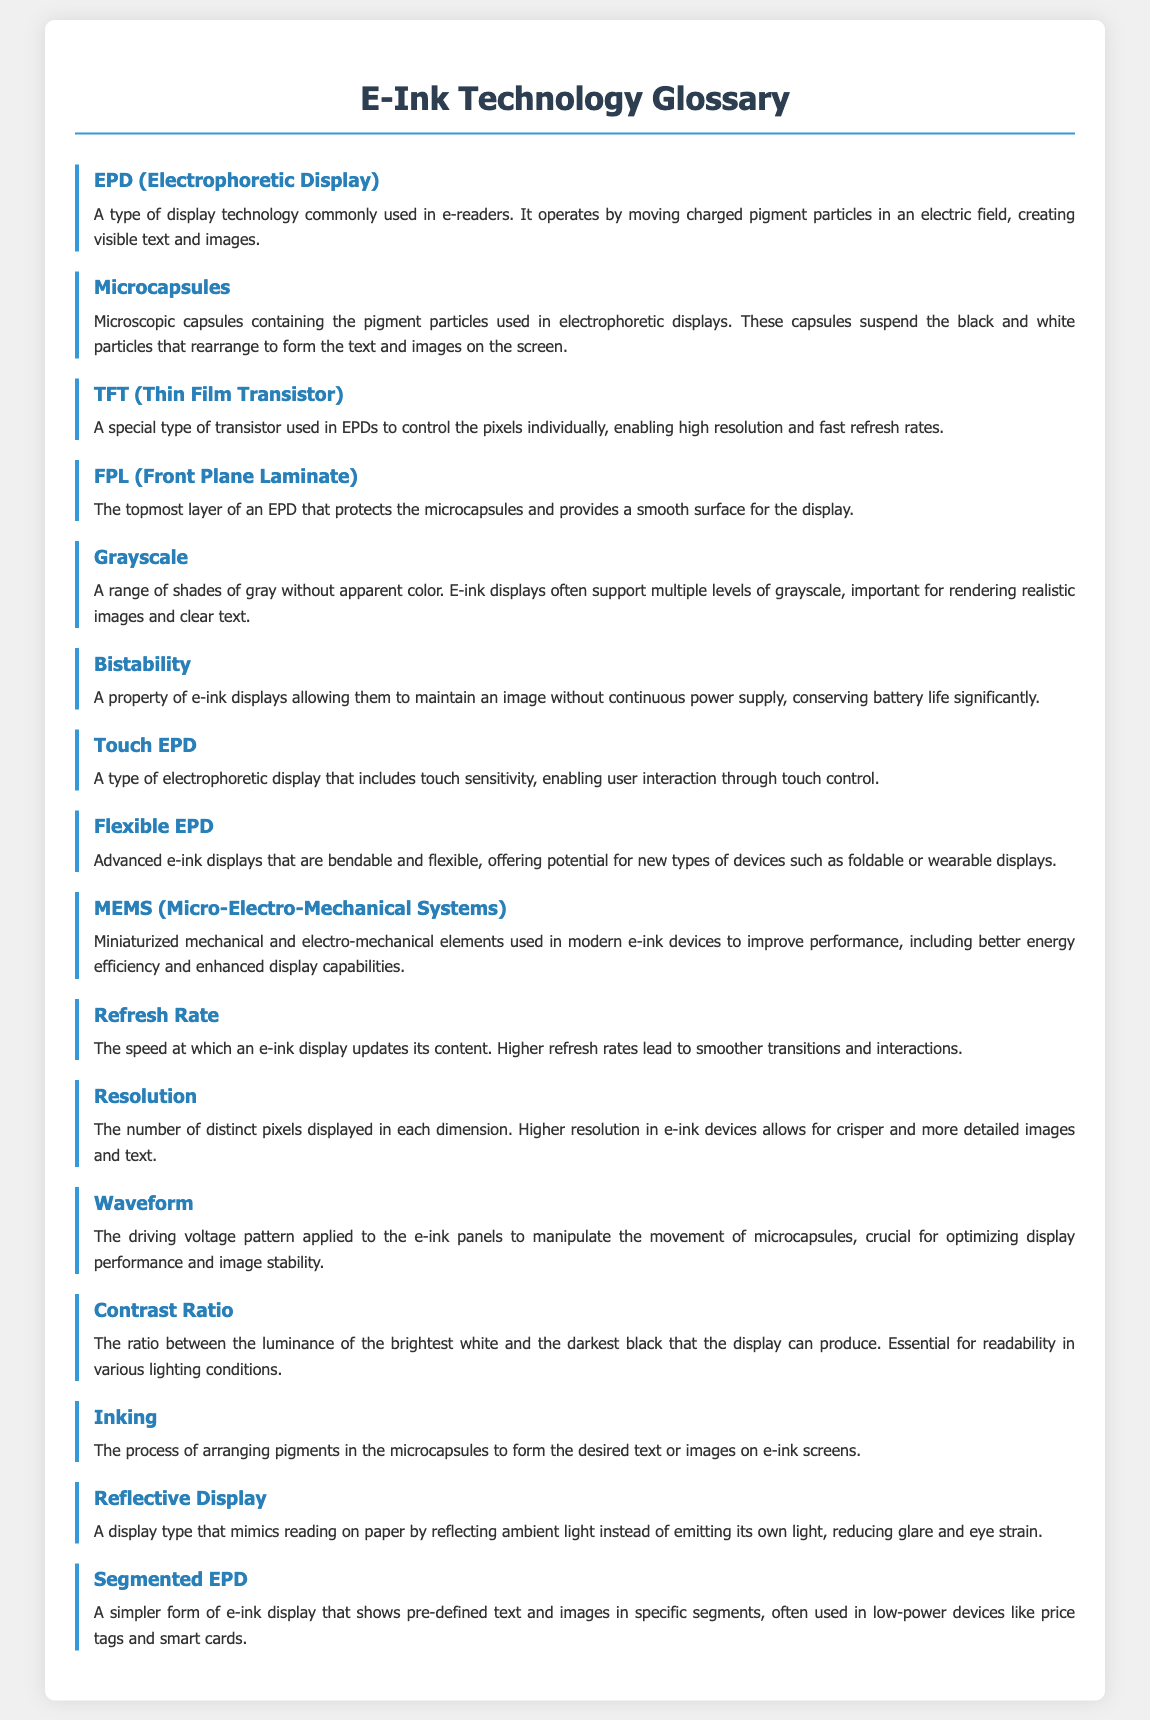What does EPD stand for? EPD is defined in the glossary section as "Electrophoretic Display."
Answer: Electrophoretic Display What is the primary function of microcapsules in EPDs? The document states that microcapsules contain pigment particles that "suspend the black and white particles that rearrange to form the text and images."
Answer: Suspend pigment particles What is the purpose of a TFT in an EPD? The definition provided indicates that TFT controls pixels "individually, enabling high resolution and fast refresh rates."
Answer: Control pixels What type of display is a Touch EPD? The document describes it as "a type of electrophoretic display that includes touch sensitivity."
Answer: Electrophoretic display How does bistability benefit e-ink displays? Bistability allows e-ink displays to "maintain an image without continuous power supply," which conserves battery life.
Answer: Conserve battery life What color range does grayscale refer to in e-ink displays? Grayscale is defined as "a range of shades of gray without apparent color."
Answer: Shades of gray Which display type reduces glare and eye strain? The glossary describes a Reflective Display as one that "mimics reading on paper by reflecting ambient light."
Answer: Reflective Display What is the role of waveform in e-ink technology? The document explains that waveforms are "the driving voltage pattern applied to the e-ink panels to manipulate the movement of microcapsules."
Answer: Manipulate microcapsules What type of device often uses segmented EPDs? The glossary indicates segmented EPDs are used in "low-power devices like price tags and smart cards."
Answer: Price tags and smart cards 